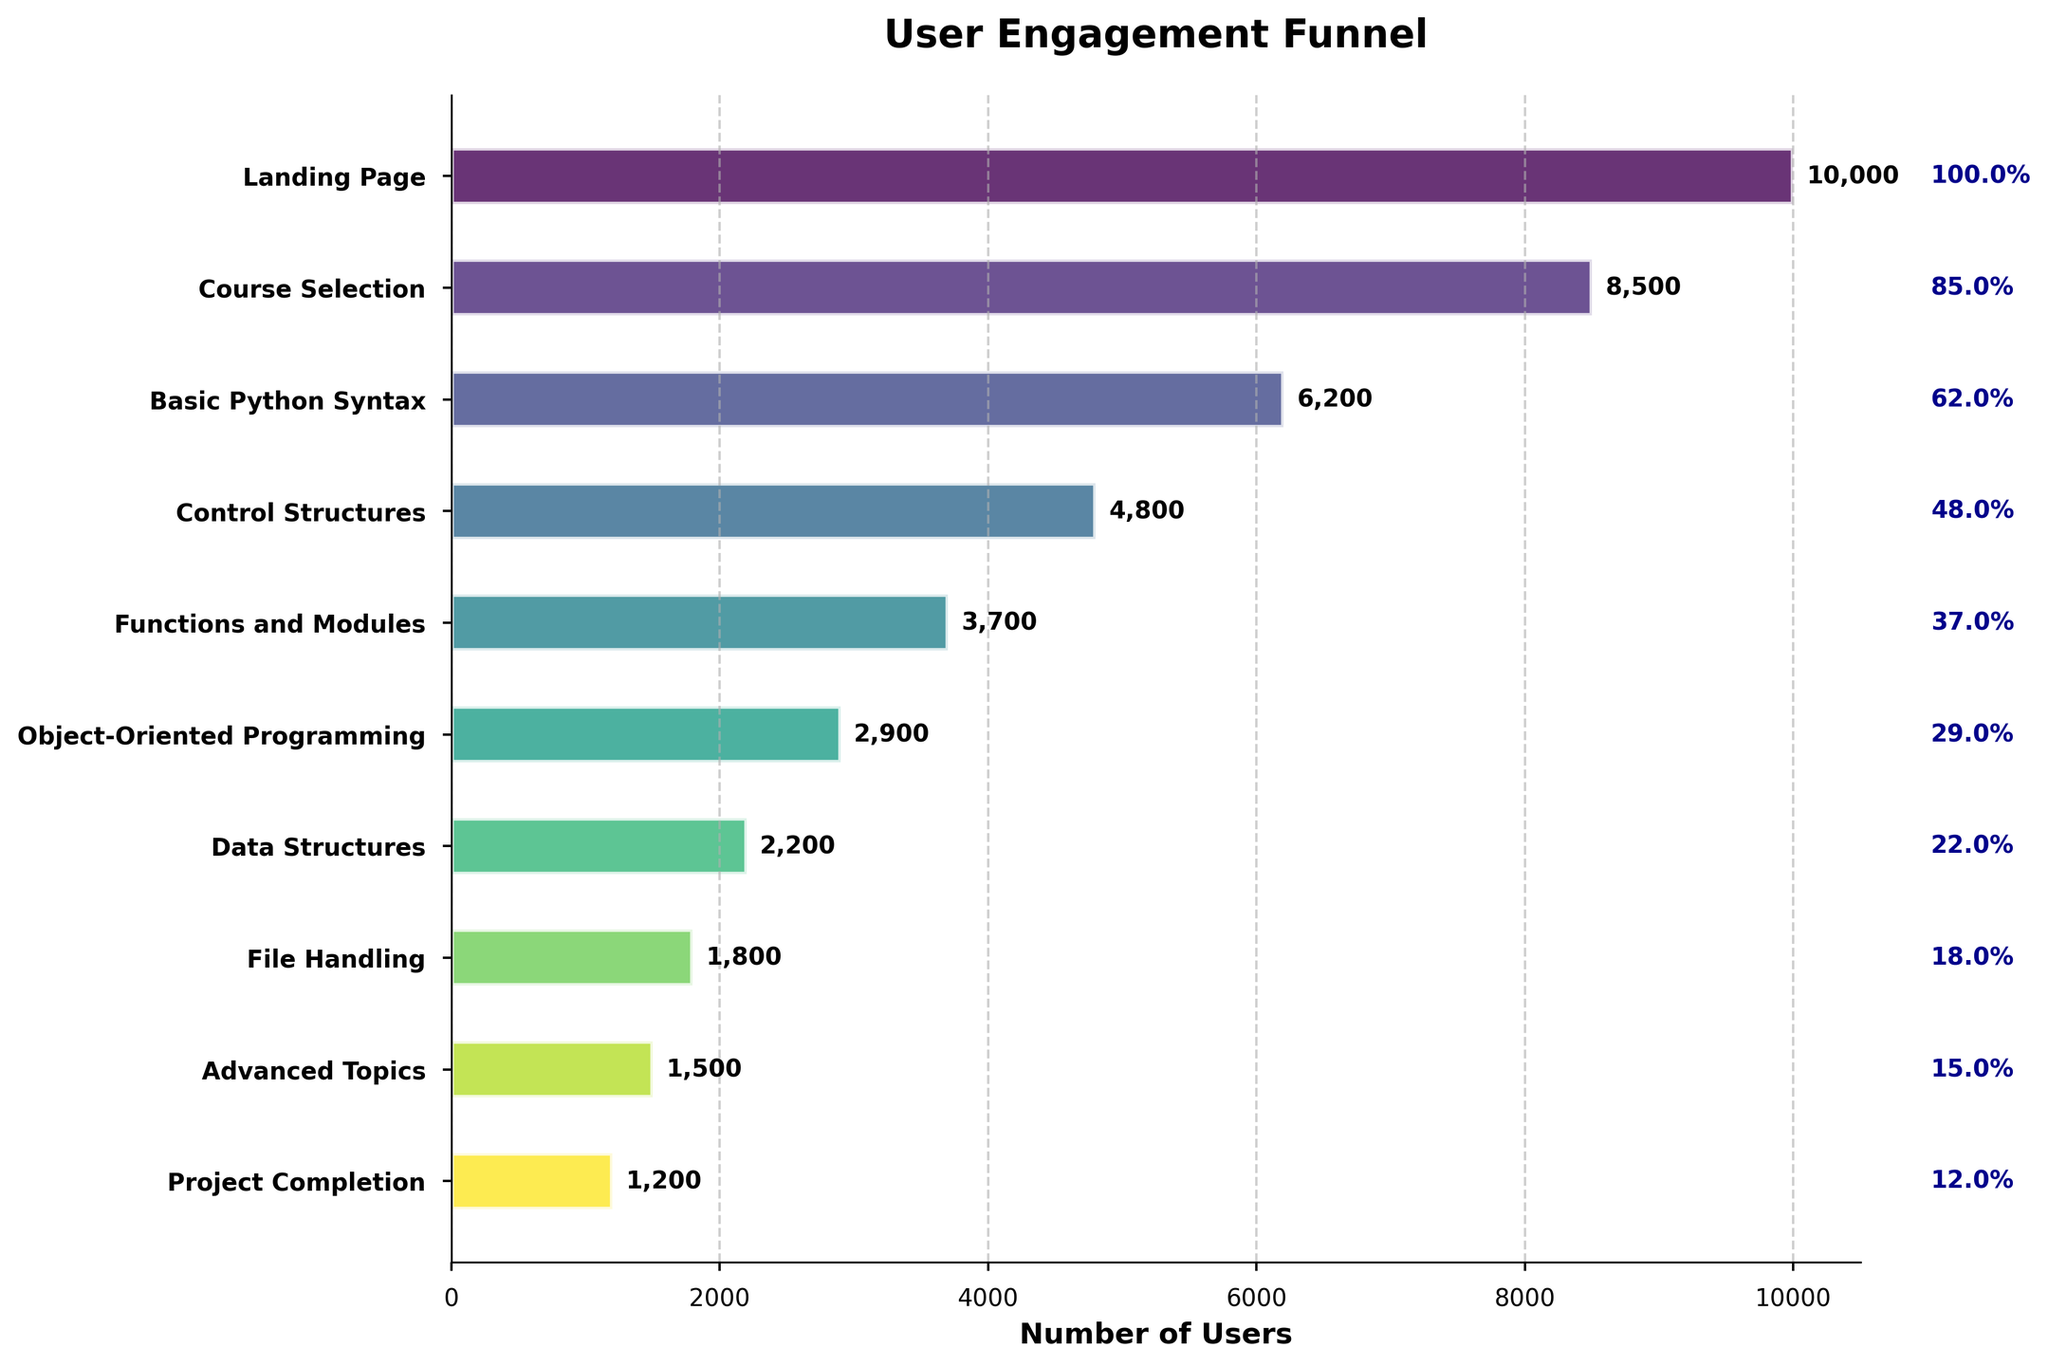What is the title of the figure? The title of the figure is displayed prominently at the top of the chart. It reads "User Engagement Funnel".
Answer: User Engagement Funnel What is the label of the x-axis? The label of the x-axis is located along the horizontal axis. It reads "Number of Users".
Answer: Number of Users How many user stages are presented in the funnel chart? By counting the labels on the y-axis or the bars themselves, one can determine there are 10 user stages shown in the chart.
Answer: 10 Which stage has the highest number of users? The first stage, "Landing Page", has the highest number of users, as indicated by the longest bar on the chart reaching 10,000 users.
Answer: Landing Page Which stage has the lowest number of users? The last stage, "Project Completion", shows the lowest number of users with a count of 1,200, evidenced by the shortest bar.
Answer: Project Completion What percentage of users progressed from the "Control Structures" stage to the "Functions and Modules" stage? The "Control Structures" stage has 4,800 users and the "Functions and Modules" stage has 3,700 users. The percentage is calculated as (3,700 / 4,800) * 100, yielding approximately 77.1%.
Answer: 77.1% How many users did not progress beyond the "Basic Python Syntax" stage? The "Basic Python Syntax" stage has 6,200 users and the "Control Structures" stage has 4,800 users. The difference is 6,200 - 4,800 = 1,400 users.
Answer: 1,400 What is the total number of users who completed the "Object-Oriented Programming", "Data Structures", "File Handling", and "Advanced Topics" stages combined? Summing up the users at each of these stages: 2,900 (Object-Oriented Programming) + 2,200 (Data Structures) + 1,800 (File Handling) + 1,500 (Advanced Topics) results in 8,400 users.
Answer: 8,400 What is the overall drop-off rate from the "Landing Page" to "Project Completion"? Starting with 10,000 users at the "Landing Page" and ending with 1,200 users at "Project Completion", the drop-off rate is ((10,000 - 1,200) / 10,000) * 100 = 88%.
Answer: 88% 